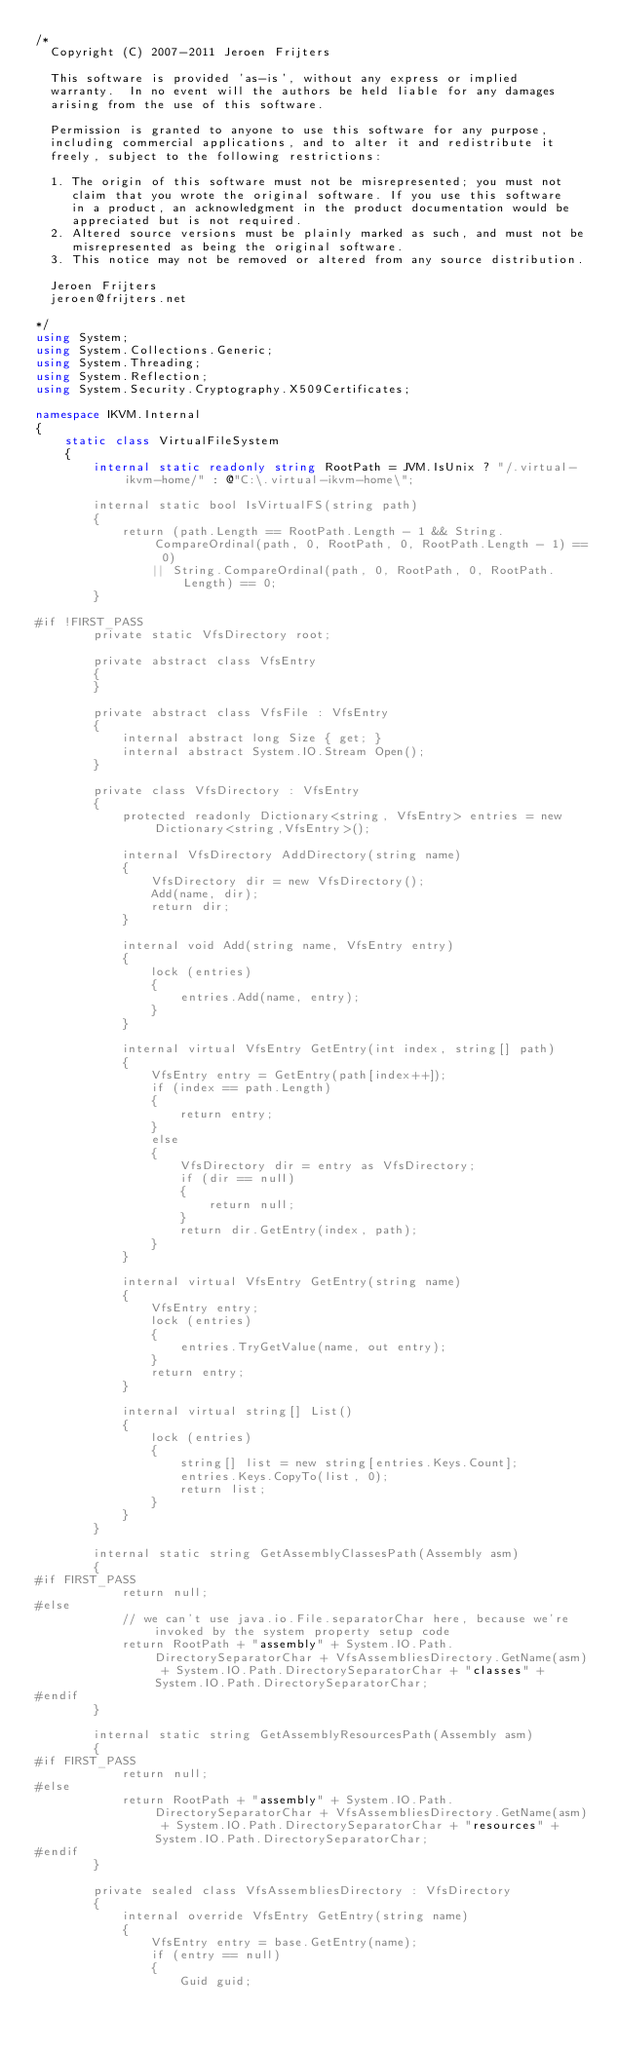Convert code to text. <code><loc_0><loc_0><loc_500><loc_500><_C#_>/*
  Copyright (C) 2007-2011 Jeroen Frijters

  This software is provided 'as-is', without any express or implied
  warranty.  In no event will the authors be held liable for any damages
  arising from the use of this software.

  Permission is granted to anyone to use this software for any purpose,
  including commercial applications, and to alter it and redistribute it
  freely, subject to the following restrictions:

  1. The origin of this software must not be misrepresented; you must not
     claim that you wrote the original software. If you use this software
     in a product, an acknowledgment in the product documentation would be
     appreciated but is not required.
  2. Altered source versions must be plainly marked as such, and must not be
     misrepresented as being the original software.
  3. This notice may not be removed or altered from any source distribution.

  Jeroen Frijters
  jeroen@frijters.net
  
*/
using System;
using System.Collections.Generic;
using System.Threading;
using System.Reflection;
using System.Security.Cryptography.X509Certificates;

namespace IKVM.Internal
{
	static class VirtualFileSystem
	{
		internal static readonly string RootPath = JVM.IsUnix ? "/.virtual-ikvm-home/" : @"C:\.virtual-ikvm-home\";

		internal static bool IsVirtualFS(string path)
		{
			return (path.Length == RootPath.Length - 1 && String.CompareOrdinal(path, 0, RootPath, 0, RootPath.Length - 1) == 0)
				|| String.CompareOrdinal(path, 0, RootPath, 0, RootPath.Length) == 0;
		}

#if !FIRST_PASS
		private static VfsDirectory root;

		private abstract class VfsEntry
		{
		}

		private abstract class VfsFile : VfsEntry
		{
			internal abstract long Size { get; }
			internal abstract System.IO.Stream Open();
		}

		private class VfsDirectory : VfsEntry
		{
			protected readonly Dictionary<string, VfsEntry> entries = new Dictionary<string,VfsEntry>();

			internal VfsDirectory AddDirectory(string name)
			{
				VfsDirectory dir = new VfsDirectory();
				Add(name, dir);
				return dir;
			}

			internal void Add(string name, VfsEntry entry)
			{
				lock (entries)
				{
					entries.Add(name, entry);
				}
			}

			internal virtual VfsEntry GetEntry(int index, string[] path)
			{
				VfsEntry entry = GetEntry(path[index++]);
				if (index == path.Length)
				{
					return entry;
				}
				else
				{
					VfsDirectory dir = entry as VfsDirectory;
					if (dir == null)
					{
						return null;
					}
					return dir.GetEntry(index, path);
				}
			}

			internal virtual VfsEntry GetEntry(string name)
			{
				VfsEntry entry;
				lock (entries)
				{
					entries.TryGetValue(name, out entry);
				}
				return entry;
			}

			internal virtual string[] List()
			{
				lock (entries)
				{
					string[] list = new string[entries.Keys.Count];
					entries.Keys.CopyTo(list, 0);
					return list;
				}
			}
		}

		internal static string GetAssemblyClassesPath(Assembly asm)
		{
#if FIRST_PASS
			return null;
#else
			// we can't use java.io.File.separatorChar here, because we're invoked by the system property setup code
			return RootPath + "assembly" + System.IO.Path.DirectorySeparatorChar + VfsAssembliesDirectory.GetName(asm) + System.IO.Path.DirectorySeparatorChar + "classes" + System.IO.Path.DirectorySeparatorChar;
#endif
		}

		internal static string GetAssemblyResourcesPath(Assembly asm)
		{
#if FIRST_PASS
			return null;
#else
			return RootPath + "assembly" + System.IO.Path.DirectorySeparatorChar + VfsAssembliesDirectory.GetName(asm) + System.IO.Path.DirectorySeparatorChar + "resources" + System.IO.Path.DirectorySeparatorChar;
#endif
		}

		private sealed class VfsAssembliesDirectory : VfsDirectory
		{
			internal override VfsEntry GetEntry(string name)
			{
				VfsEntry entry = base.GetEntry(name);
				if (entry == null)
				{
					Guid guid;</code> 